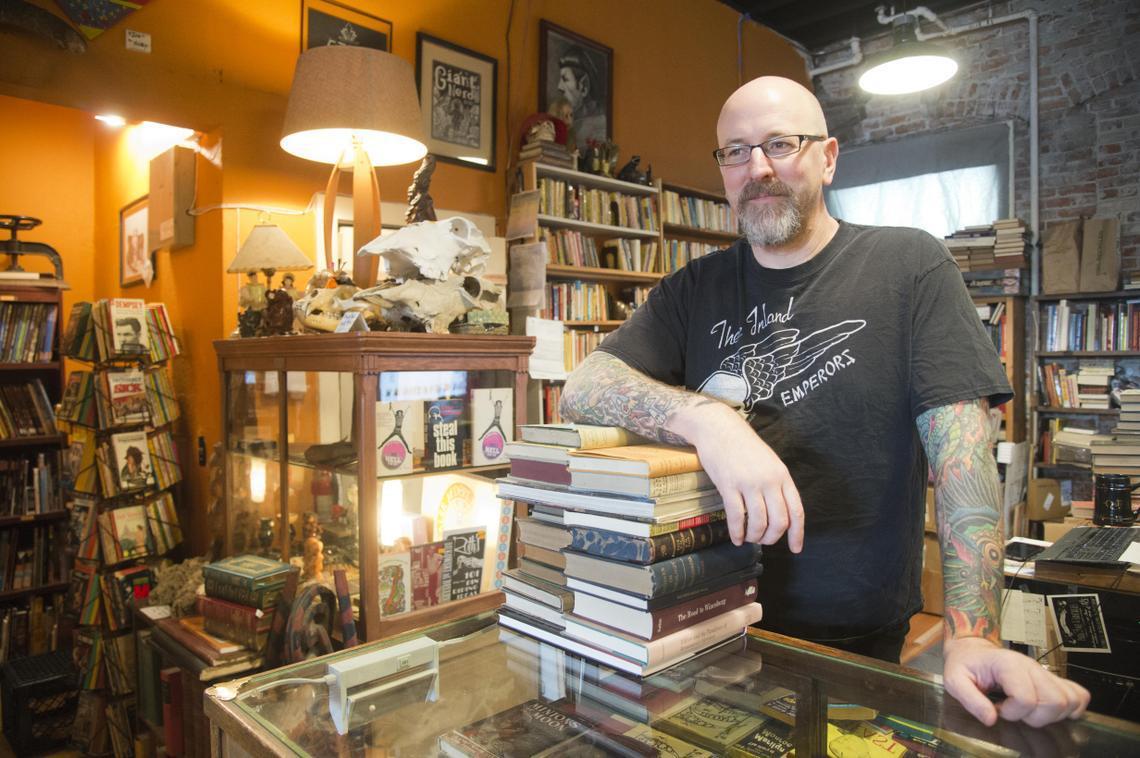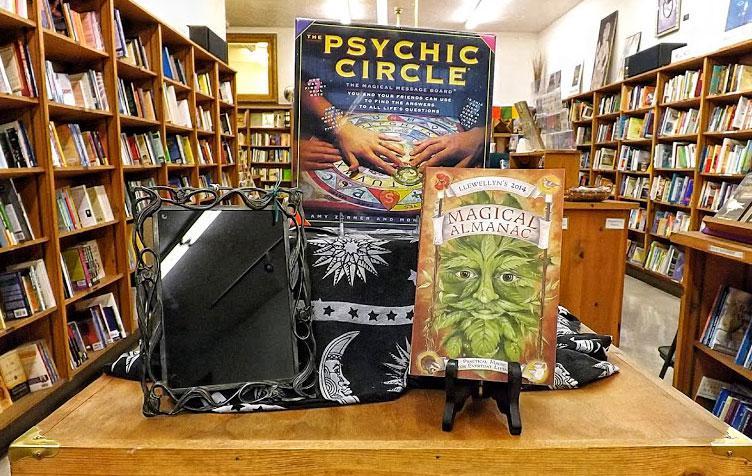The first image is the image on the left, the second image is the image on the right. Evaluate the accuracy of this statement regarding the images: "A man with a gray beard and glasses stands behind a counter stacked with books in one image, and the other image shows a display with a book's front cover.". Is it true? Answer yes or no. Yes. The first image is the image on the left, the second image is the image on the right. Assess this claim about the two images: "In one image there is a man with a beard in a bookstore.". Correct or not? Answer yes or no. Yes. 